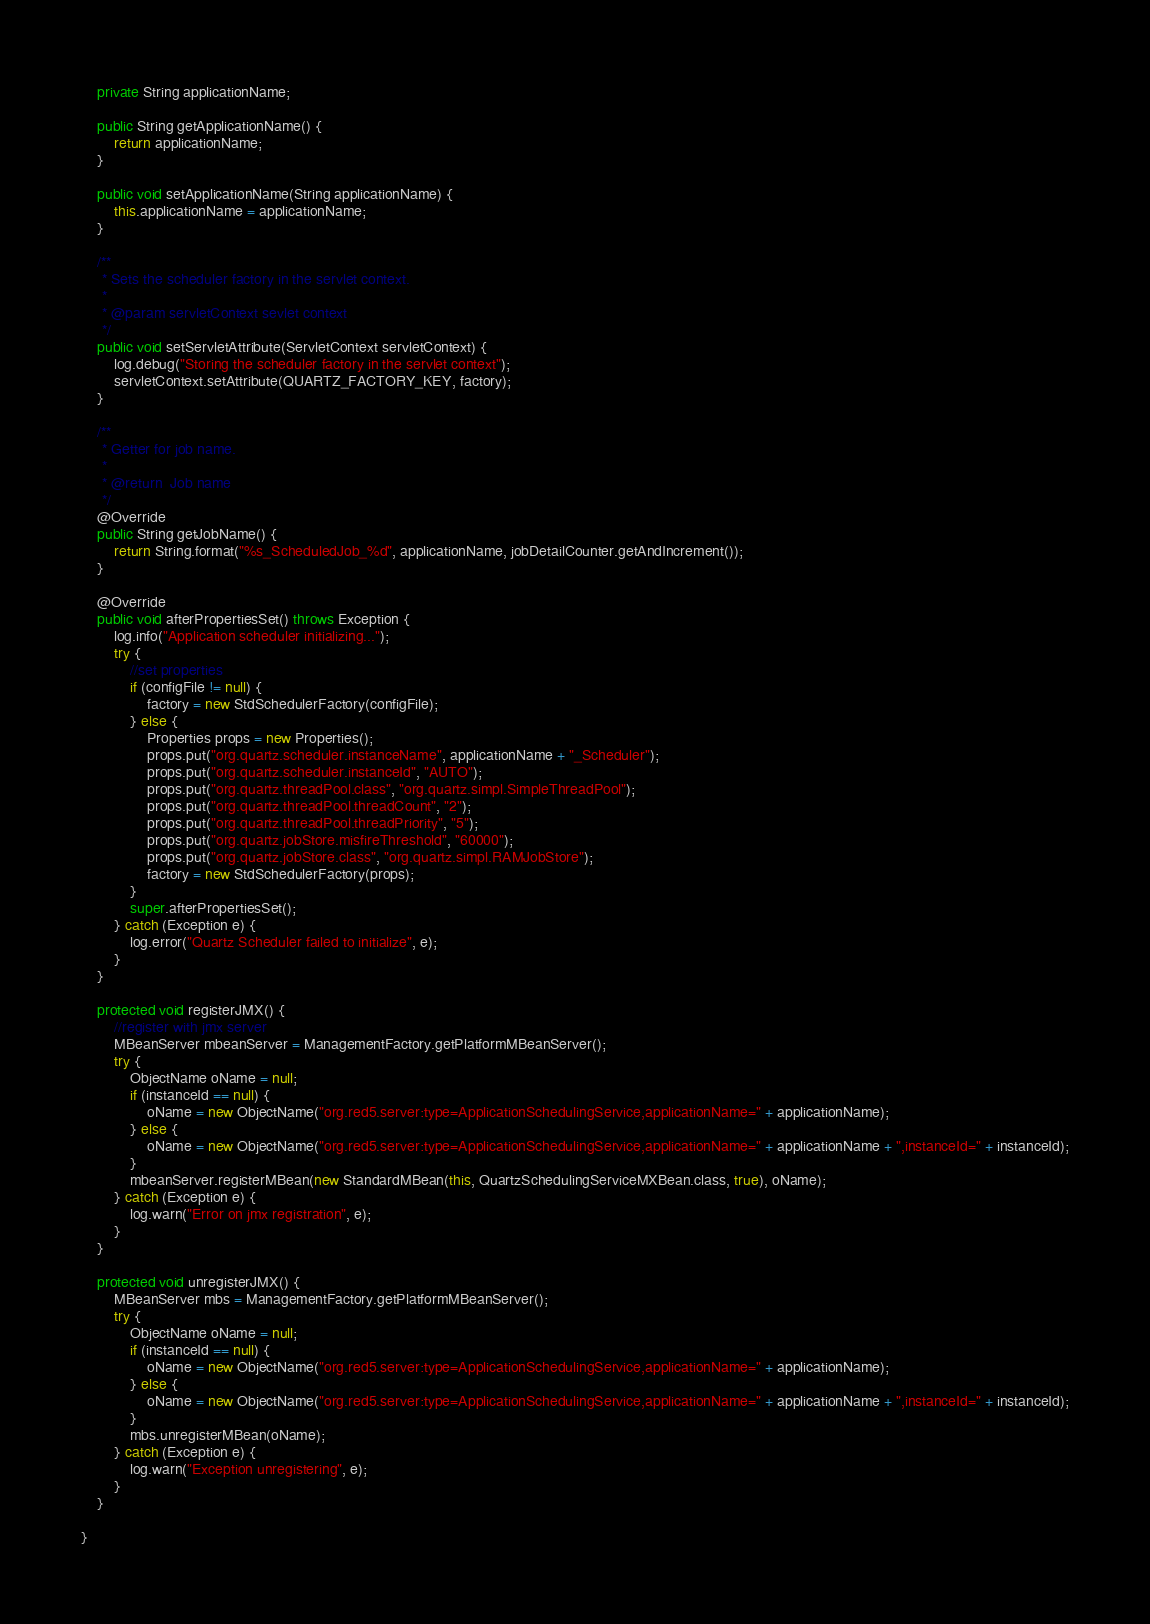<code> <loc_0><loc_0><loc_500><loc_500><_Java_>
	private String applicationName;

	public String getApplicationName() {
		return applicationName;
	}

	public void setApplicationName(String applicationName) {
		this.applicationName = applicationName;
	}

	/**
	 * Sets the scheduler factory in the servlet context.
	 * 
	 * @param servletContext sevlet context
	 */
	public void setServletAttribute(ServletContext servletContext) {
		log.debug("Storing the scheduler factory in the servlet context");
		servletContext.setAttribute(QUARTZ_FACTORY_KEY, factory);
	}

	/**
	 * Getter for job name.
	 *
	 * @return  Job name
	 */
	@Override
	public String getJobName() {
		return String.format("%s_ScheduledJob_%d", applicationName, jobDetailCounter.getAndIncrement());
	}	
	
	@Override
	public void afterPropertiesSet() throws Exception {
		log.info("Application scheduler initializing...");
		try {
			//set properties
			if (configFile != null) {
				factory = new StdSchedulerFactory(configFile);
			} else {
				Properties props = new Properties();
				props.put("org.quartz.scheduler.instanceName", applicationName + "_Scheduler");
				props.put("org.quartz.scheduler.instanceId", "AUTO");
				props.put("org.quartz.threadPool.class", "org.quartz.simpl.SimpleThreadPool");
				props.put("org.quartz.threadPool.threadCount", "2");
				props.put("org.quartz.threadPool.threadPriority", "5");
				props.put("org.quartz.jobStore.misfireThreshold", "60000");
				props.put("org.quartz.jobStore.class", "org.quartz.simpl.RAMJobStore");
				factory = new StdSchedulerFactory(props);
			}
			super.afterPropertiesSet();
		} catch (Exception e) {
			log.error("Quartz Scheduler failed to initialize", e);
		}
	}

	protected void registerJMX() {
		//register with jmx server
		MBeanServer mbeanServer = ManagementFactory.getPlatformMBeanServer();
		try {
			ObjectName oName = null;
			if (instanceId == null) {
				oName = new ObjectName("org.red5.server:type=ApplicationSchedulingService,applicationName=" + applicationName);
			} else {
				oName = new ObjectName("org.red5.server:type=ApplicationSchedulingService,applicationName=" + applicationName + ",instanceId=" + instanceId);
			}
			mbeanServer.registerMBean(new StandardMBean(this, QuartzSchedulingServiceMXBean.class, true), oName);
		} catch (Exception e) {
			log.warn("Error on jmx registration", e);
		}
	}

	protected void unregisterJMX() {
		MBeanServer mbs = ManagementFactory.getPlatformMBeanServer();
		try {
			ObjectName oName = null;
			if (instanceId == null) {
				oName = new ObjectName("org.red5.server:type=ApplicationSchedulingService,applicationName=" + applicationName);
			} else {
				oName = new ObjectName("org.red5.server:type=ApplicationSchedulingService,applicationName=" + applicationName + ",instanceId=" + instanceId);
			}
			mbs.unregisterMBean(oName);
		} catch (Exception e) {
			log.warn("Exception unregistering", e);
		}
	}

}
</code> 